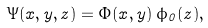<formula> <loc_0><loc_0><loc_500><loc_500>\Psi ( x , y , z ) = \Phi ( x , y ) \, \phi _ { 0 } ( z ) ,</formula> 